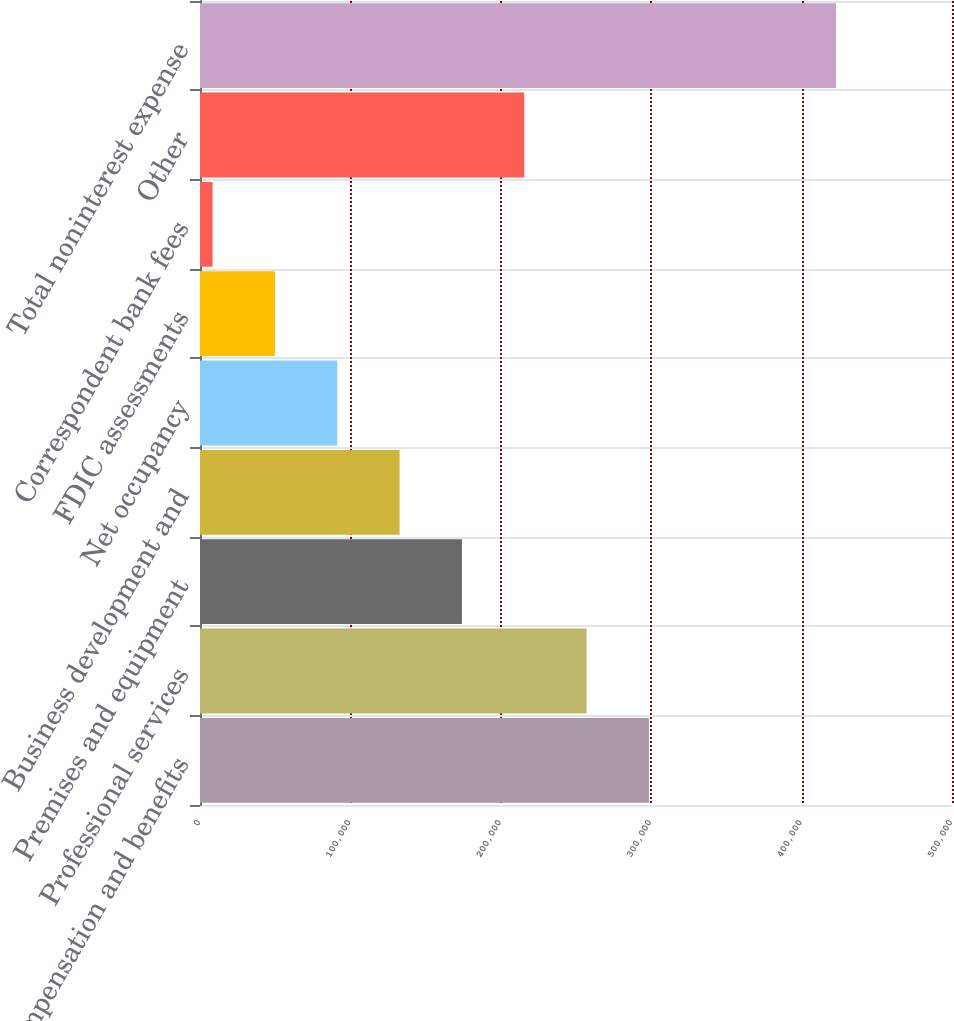Convert chart. <chart><loc_0><loc_0><loc_500><loc_500><bar_chart><fcel>Compensation and benefits<fcel>Professional services<fcel>Premises and equipment<fcel>Business development and<fcel>Net occupancy<fcel>FDIC assessments<fcel>Correspondent bank fees<fcel>Other<fcel>Total noninterest expense<nl><fcel>298486<fcel>257042<fcel>174155<fcel>132711<fcel>91266.8<fcel>49822.9<fcel>8379<fcel>215598<fcel>422818<nl></chart> 